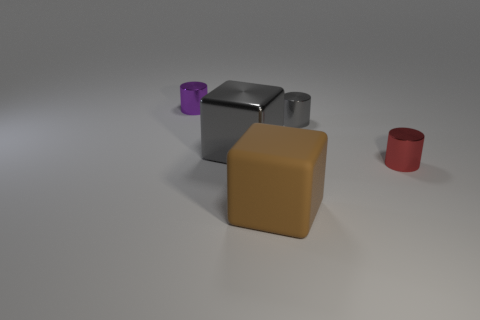Add 1 purple cylinders. How many objects exist? 6 Add 3 tiny purple shiny cylinders. How many tiny purple shiny cylinders are left? 4 Add 2 large brown matte cubes. How many large brown matte cubes exist? 3 Subtract 0 brown spheres. How many objects are left? 5 Subtract all cubes. How many objects are left? 3 Subtract all brown cylinders. Subtract all cyan spheres. How many cylinders are left? 3 Subtract all big matte cubes. Subtract all big objects. How many objects are left? 2 